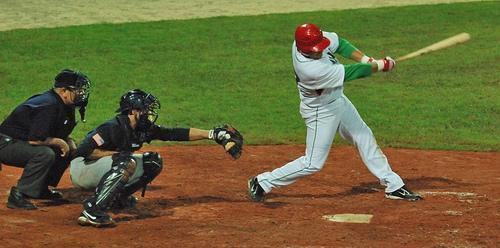How many people are in this picture?
Give a very brief answer. 3. How many people are wearing a face mask?
Give a very brief answer. 2. 